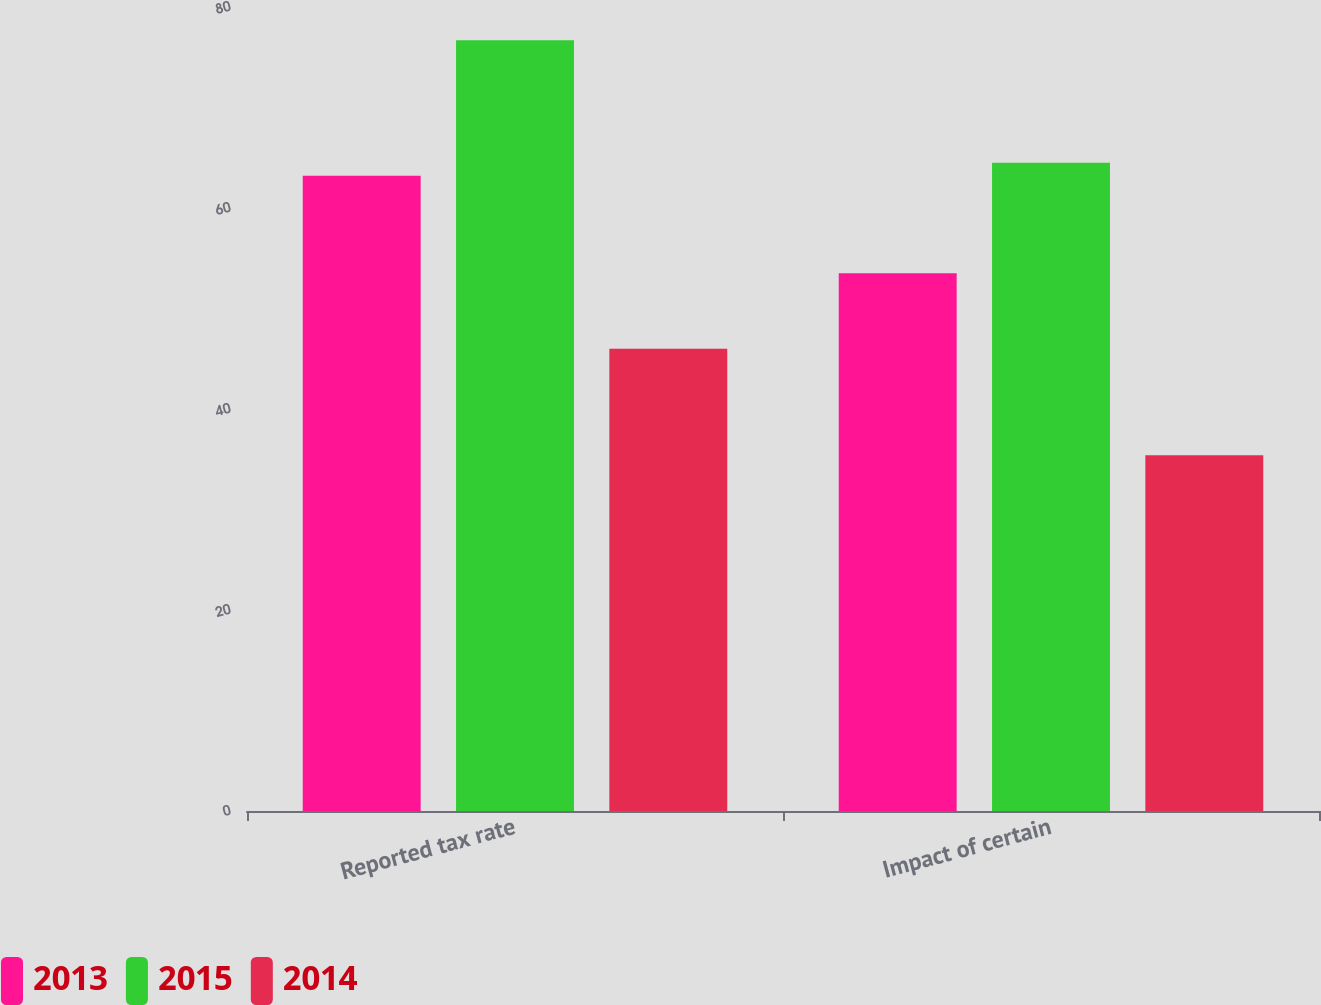Convert chart. <chart><loc_0><loc_0><loc_500><loc_500><stacked_bar_chart><ecel><fcel>Reported tax rate<fcel>Impact of certain<nl><fcel>2013<fcel>63.2<fcel>53.5<nl><fcel>2015<fcel>76.7<fcel>64.5<nl><fcel>2014<fcel>46<fcel>35.4<nl></chart> 